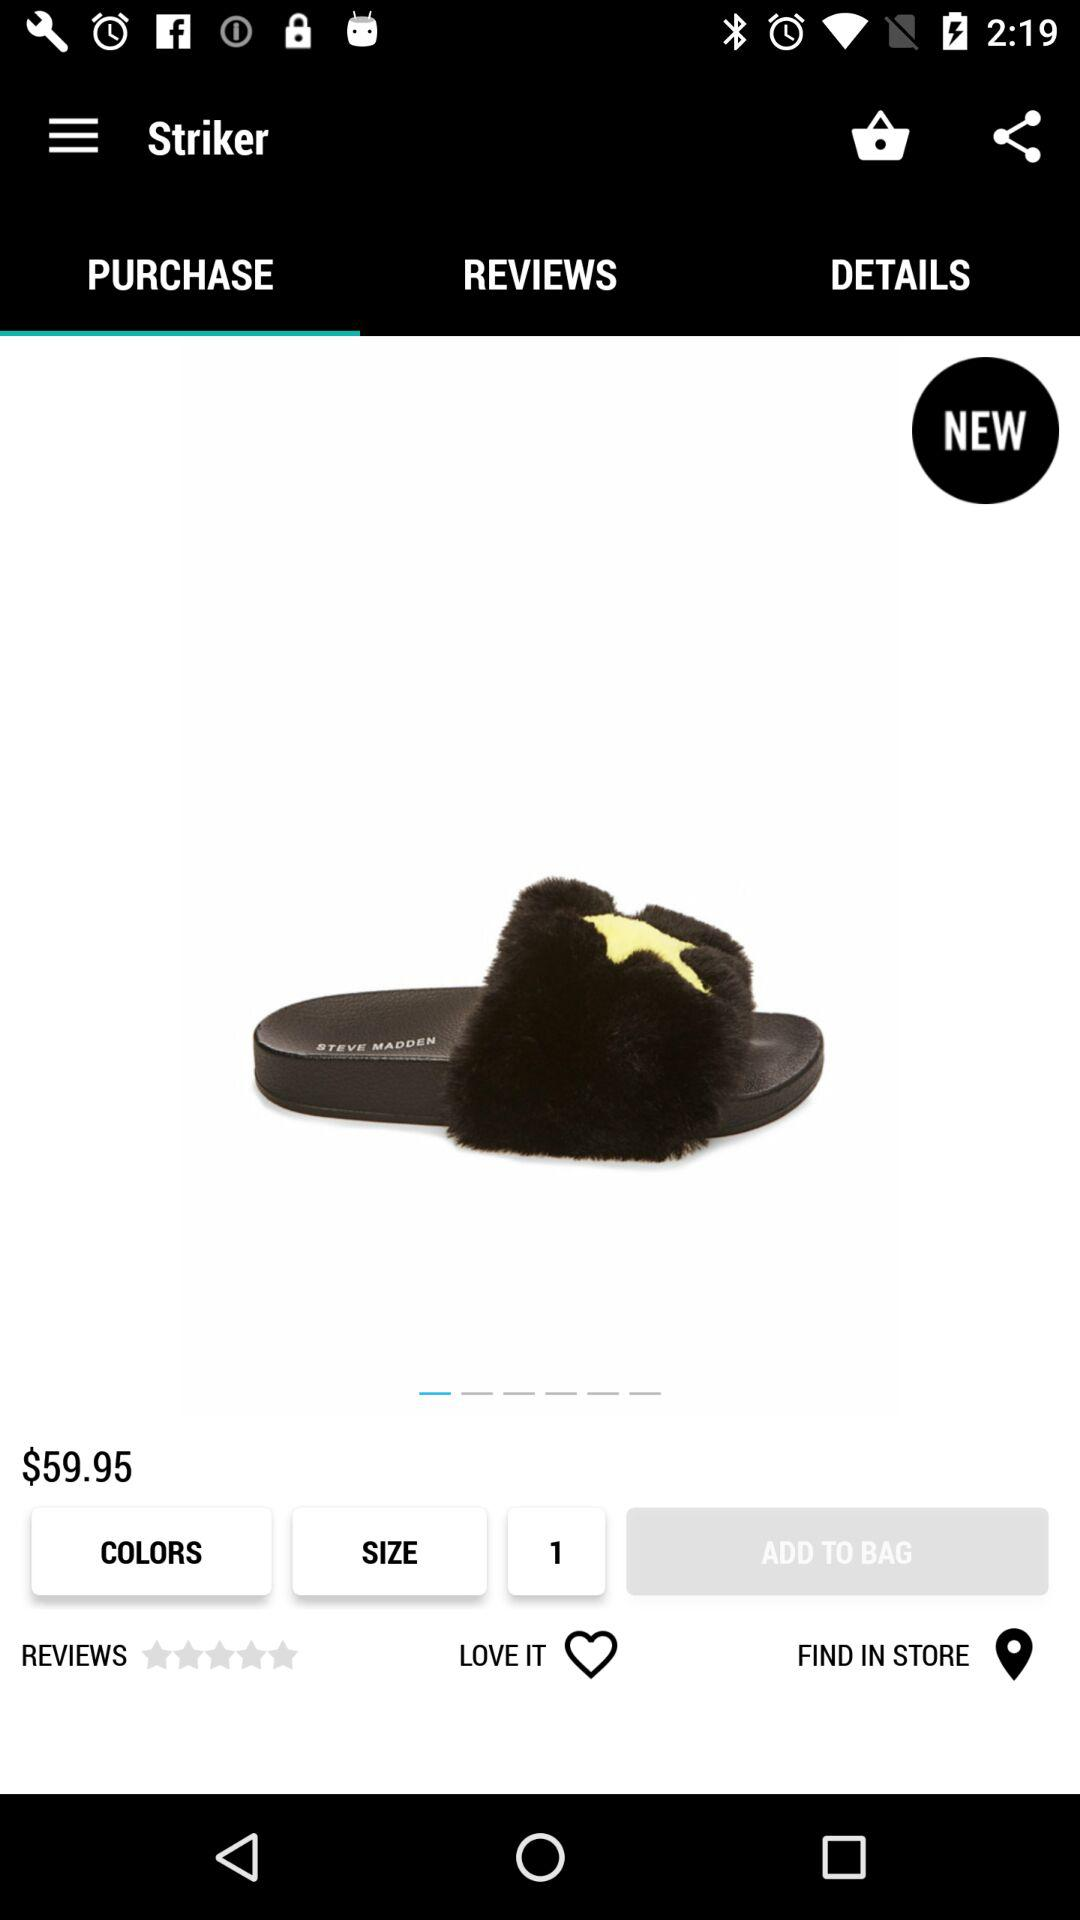How much is the product?
Answer the question using a single word or phrase. $59.95 